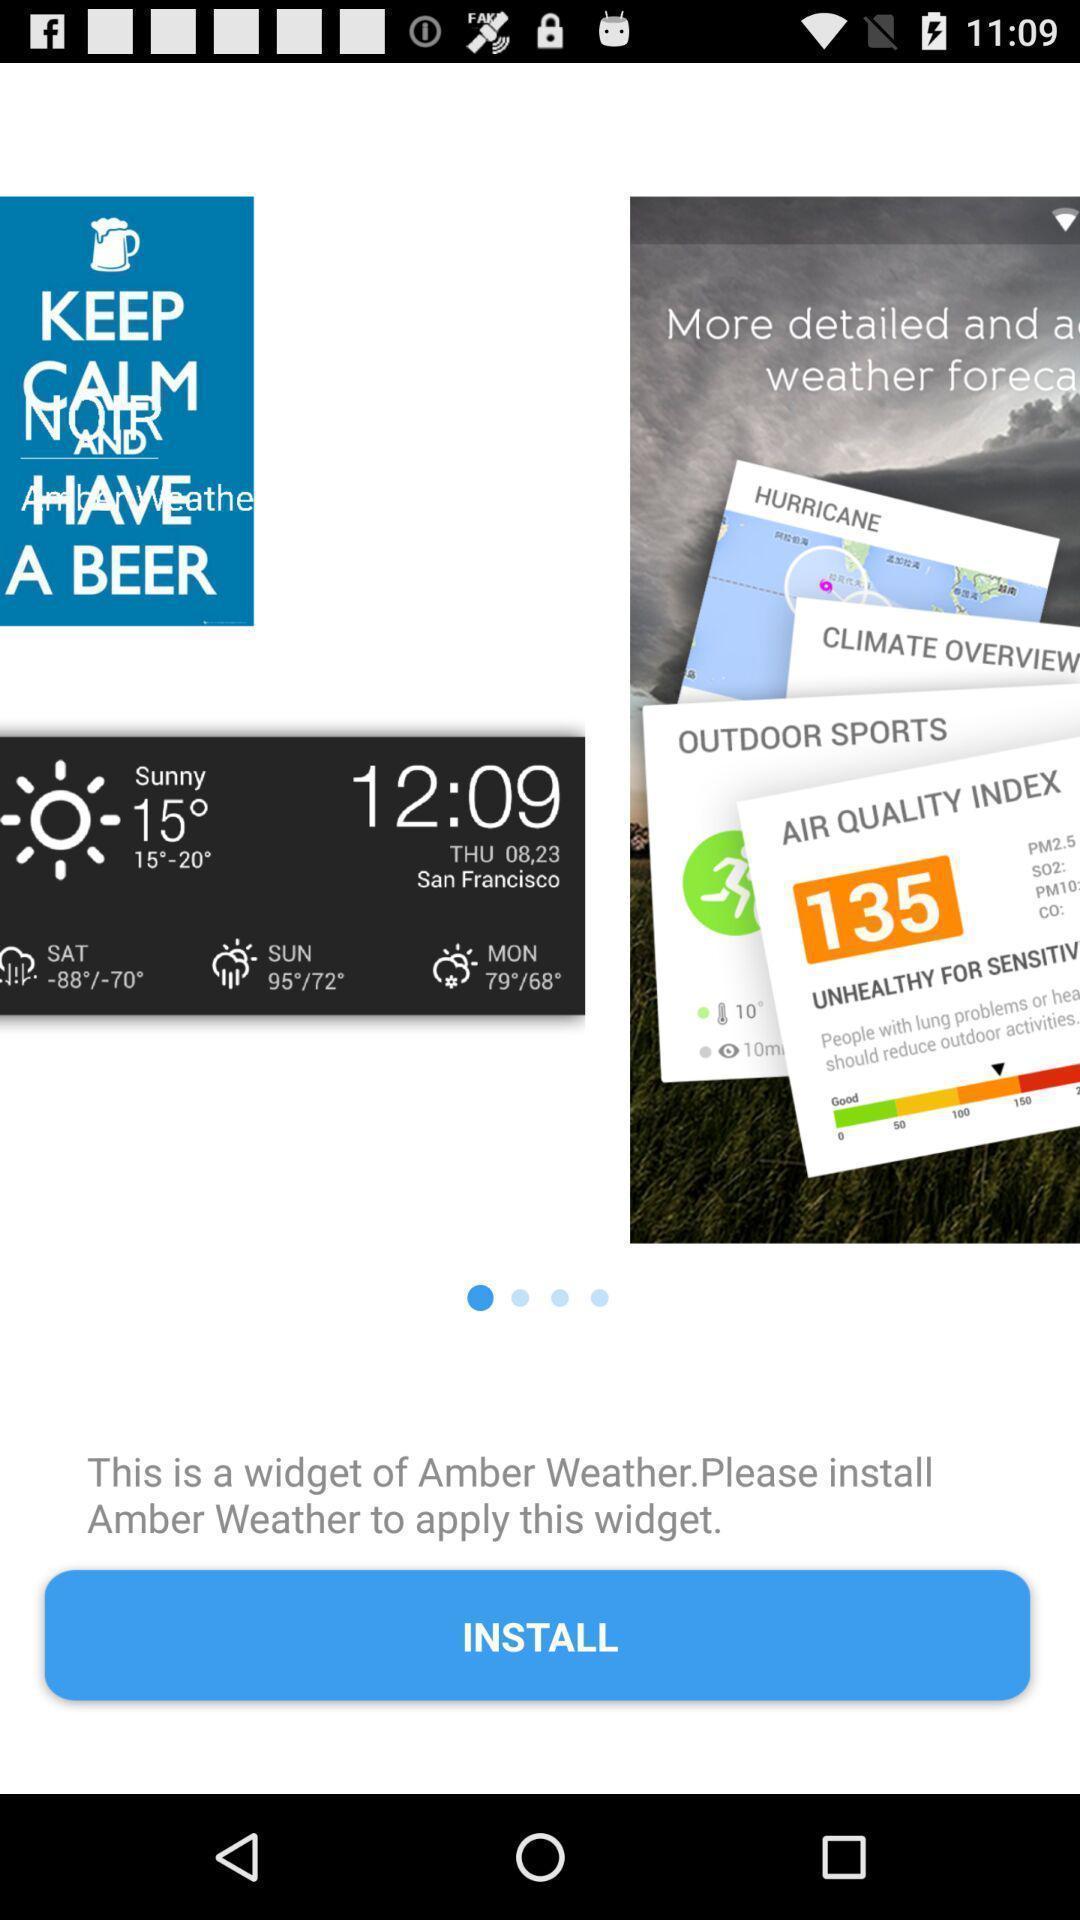Summarize the information in this screenshot. Welcome page. 